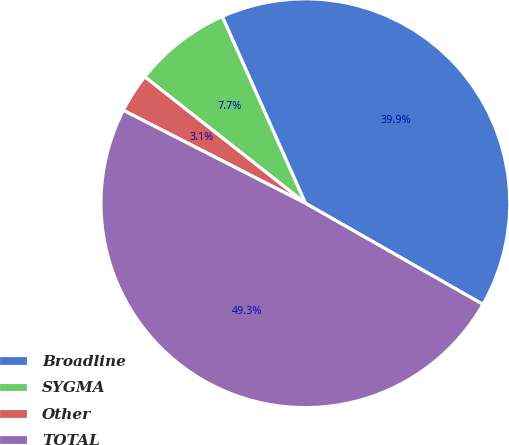<chart> <loc_0><loc_0><loc_500><loc_500><pie_chart><fcel>Broadline<fcel>SYGMA<fcel>Other<fcel>TOTAL<nl><fcel>39.91%<fcel>7.72%<fcel>3.1%<fcel>49.27%<nl></chart> 